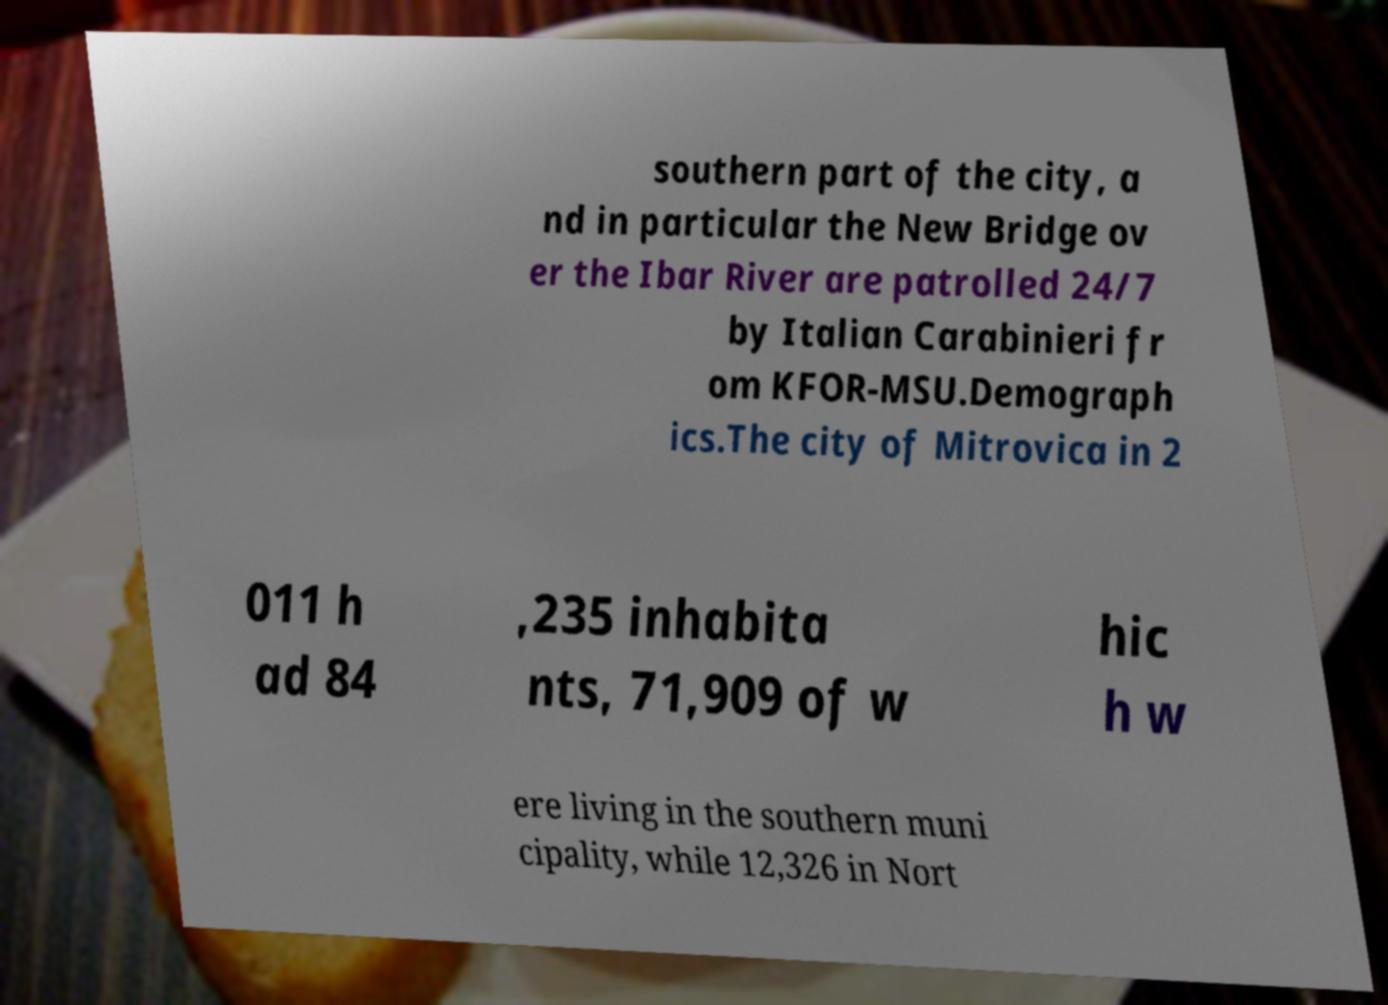Can you read and provide the text displayed in the image?This photo seems to have some interesting text. Can you extract and type it out for me? southern part of the city, a nd in particular the New Bridge ov er the Ibar River are patrolled 24/7 by Italian Carabinieri fr om KFOR-MSU.Demograph ics.The city of Mitrovica in 2 011 h ad 84 ,235 inhabita nts, 71,909 of w hic h w ere living in the southern muni cipality, while 12,326 in Nort 